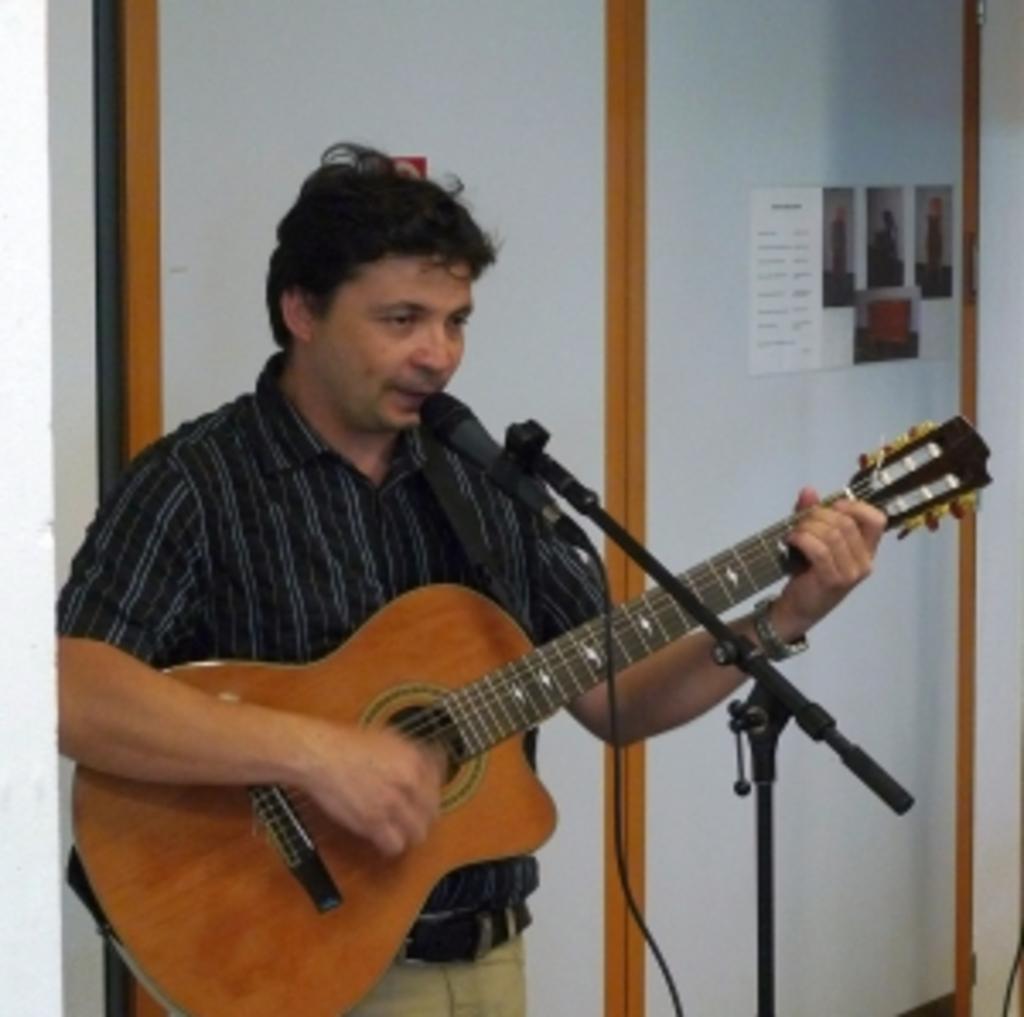Could you give a brief overview of what you see in this image? In this picture we can see man holding guitar in his hand and singing on the mic and in the background we can see wall and some notice and photos on it. 